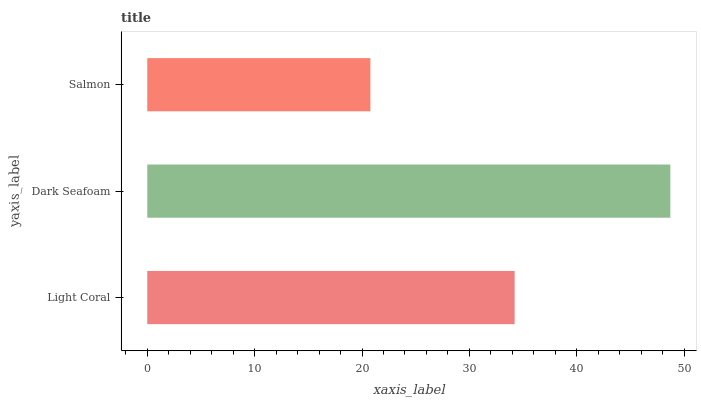Is Salmon the minimum?
Answer yes or no. Yes. Is Dark Seafoam the maximum?
Answer yes or no. Yes. Is Dark Seafoam the minimum?
Answer yes or no. No. Is Salmon the maximum?
Answer yes or no. No. Is Dark Seafoam greater than Salmon?
Answer yes or no. Yes. Is Salmon less than Dark Seafoam?
Answer yes or no. Yes. Is Salmon greater than Dark Seafoam?
Answer yes or no. No. Is Dark Seafoam less than Salmon?
Answer yes or no. No. Is Light Coral the high median?
Answer yes or no. Yes. Is Light Coral the low median?
Answer yes or no. Yes. Is Dark Seafoam the high median?
Answer yes or no. No. Is Salmon the low median?
Answer yes or no. No. 